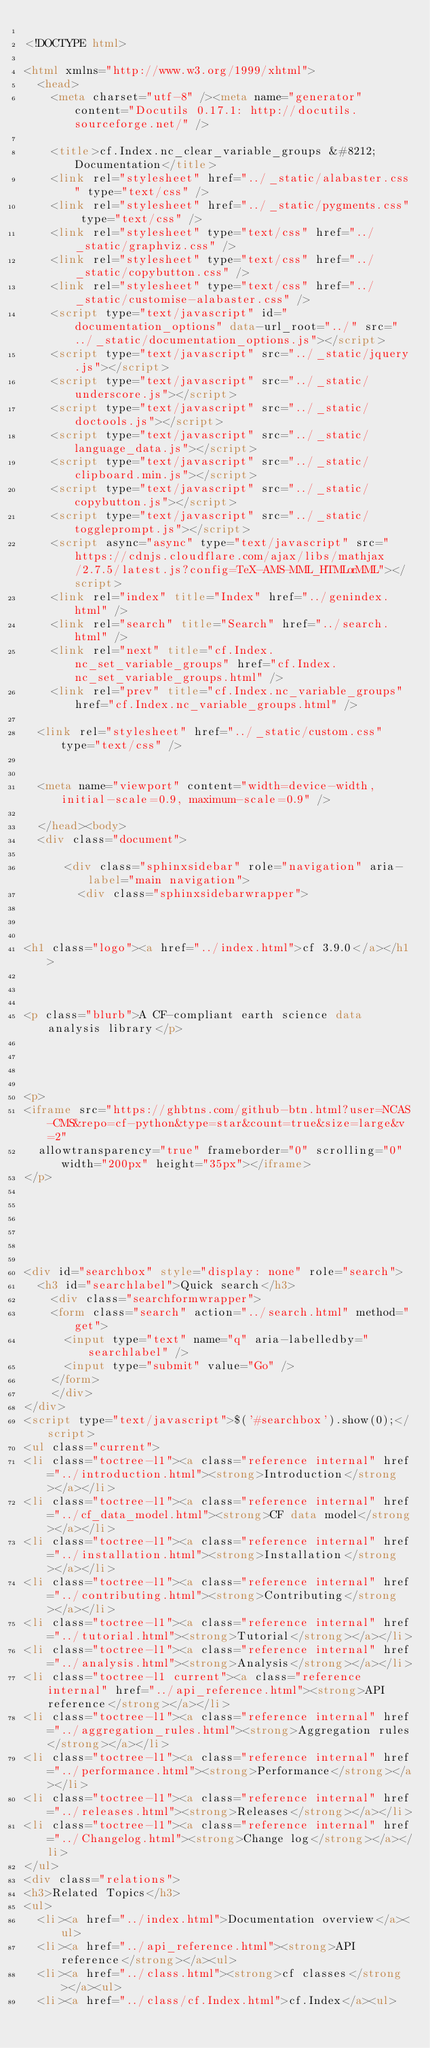Convert code to text. <code><loc_0><loc_0><loc_500><loc_500><_HTML_>
<!DOCTYPE html>

<html xmlns="http://www.w3.org/1999/xhtml">
  <head>
    <meta charset="utf-8" /><meta name="generator" content="Docutils 0.17.1: http://docutils.sourceforge.net/" />

    <title>cf.Index.nc_clear_variable_groups &#8212; Documentation</title>
    <link rel="stylesheet" href="../_static/alabaster.css" type="text/css" />
    <link rel="stylesheet" href="../_static/pygments.css" type="text/css" />
    <link rel="stylesheet" type="text/css" href="../_static/graphviz.css" />
    <link rel="stylesheet" type="text/css" href="../_static/copybutton.css" />
    <link rel="stylesheet" type="text/css" href="../_static/customise-alabaster.css" />
    <script type="text/javascript" id="documentation_options" data-url_root="../" src="../_static/documentation_options.js"></script>
    <script type="text/javascript" src="../_static/jquery.js"></script>
    <script type="text/javascript" src="../_static/underscore.js"></script>
    <script type="text/javascript" src="../_static/doctools.js"></script>
    <script type="text/javascript" src="../_static/language_data.js"></script>
    <script type="text/javascript" src="../_static/clipboard.min.js"></script>
    <script type="text/javascript" src="../_static/copybutton.js"></script>
    <script type="text/javascript" src="../_static/toggleprompt.js"></script>
    <script async="async" type="text/javascript" src="https://cdnjs.cloudflare.com/ajax/libs/mathjax/2.7.5/latest.js?config=TeX-AMS-MML_HTMLorMML"></script>
    <link rel="index" title="Index" href="../genindex.html" />
    <link rel="search" title="Search" href="../search.html" />
    <link rel="next" title="cf.Index.nc_set_variable_groups" href="cf.Index.nc_set_variable_groups.html" />
    <link rel="prev" title="cf.Index.nc_variable_groups" href="cf.Index.nc_variable_groups.html" />
   
  <link rel="stylesheet" href="../_static/custom.css" type="text/css" />
  
  
  <meta name="viewport" content="width=device-width, initial-scale=0.9, maximum-scale=0.9" />

  </head><body>
  <div class="document">
    
      <div class="sphinxsidebar" role="navigation" aria-label="main navigation">
        <div class="sphinxsidebarwrapper">



<h1 class="logo"><a href="../index.html">cf 3.9.0</a></h1>



<p class="blurb">A CF-compliant earth science data analysis library</p>




<p>
<iframe src="https://ghbtns.com/github-btn.html?user=NCAS-CMS&repo=cf-python&type=star&count=true&size=large&v=2"
  allowtransparency="true" frameborder="0" scrolling="0" width="200px" height="35px"></iframe>
</p>






<div id="searchbox" style="display: none" role="search">
  <h3 id="searchlabel">Quick search</h3>
    <div class="searchformwrapper">
    <form class="search" action="../search.html" method="get">
      <input type="text" name="q" aria-labelledby="searchlabel" />
      <input type="submit" value="Go" />
    </form>
    </div>
</div>
<script type="text/javascript">$('#searchbox').show(0);</script>
<ul class="current">
<li class="toctree-l1"><a class="reference internal" href="../introduction.html"><strong>Introduction</strong></a></li>
<li class="toctree-l1"><a class="reference internal" href="../cf_data_model.html"><strong>CF data model</strong></a></li>
<li class="toctree-l1"><a class="reference internal" href="../installation.html"><strong>Installation</strong></a></li>
<li class="toctree-l1"><a class="reference internal" href="../contributing.html"><strong>Contributing</strong></a></li>
<li class="toctree-l1"><a class="reference internal" href="../tutorial.html"><strong>Tutorial</strong></a></li>
<li class="toctree-l1"><a class="reference internal" href="../analysis.html"><strong>Analysis</strong></a></li>
<li class="toctree-l1 current"><a class="reference internal" href="../api_reference.html"><strong>API reference</strong></a></li>
<li class="toctree-l1"><a class="reference internal" href="../aggregation_rules.html"><strong>Aggregation rules</strong></a></li>
<li class="toctree-l1"><a class="reference internal" href="../performance.html"><strong>Performance</strong></a></li>
<li class="toctree-l1"><a class="reference internal" href="../releases.html"><strong>Releases</strong></a></li>
<li class="toctree-l1"><a class="reference internal" href="../Changelog.html"><strong>Change log</strong></a></li>
</ul>
<div class="relations">
<h3>Related Topics</h3>
<ul>
  <li><a href="../index.html">Documentation overview</a><ul>
  <li><a href="../api_reference.html"><strong>API reference</strong></a><ul>
  <li><a href="../class.html"><strong>cf classes</strong></a><ul>
  <li><a href="../class/cf.Index.html">cf.Index</a><ul></code> 